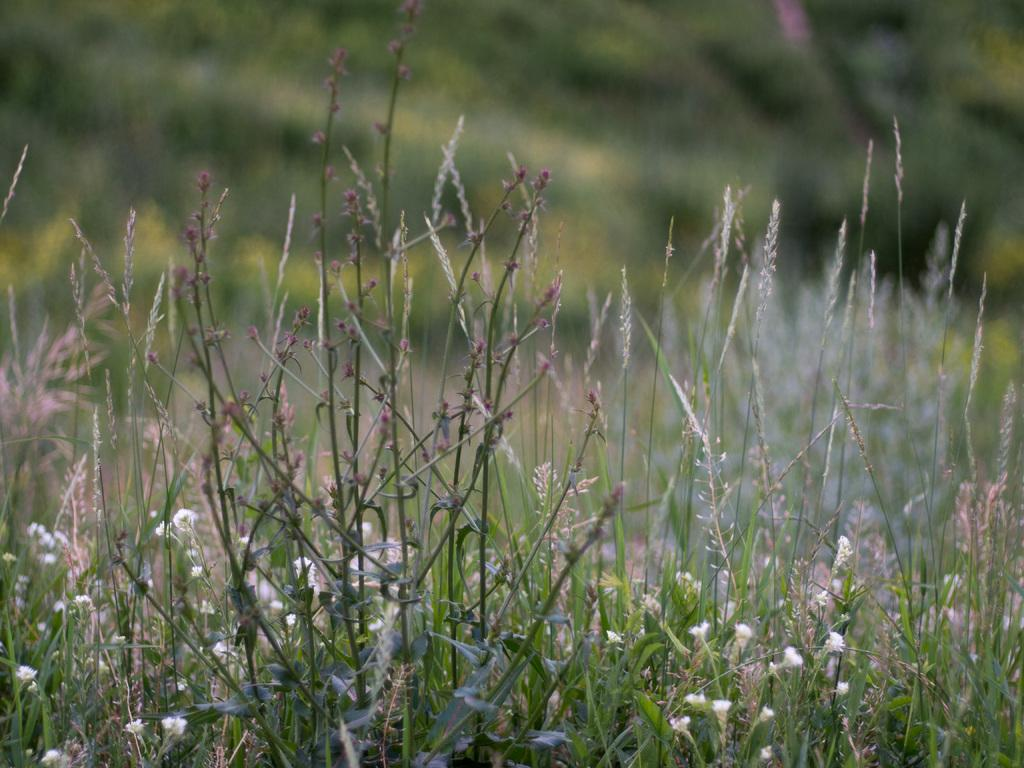What is located in the foreground of the image? There are plants in the foreground of the image. How would you describe the background of the image? The background of the image is blurred. What type of vegetation can be seen in the background of the image? There is greenery in the background of the image. What type of shop can be seen in the background of the image? There is no shop present in the image; it only features plants in the foreground and greenery in the background. How does the doctor interact with the plants in the image? There is no doctor present in the image, as it only features plants and greenery. 